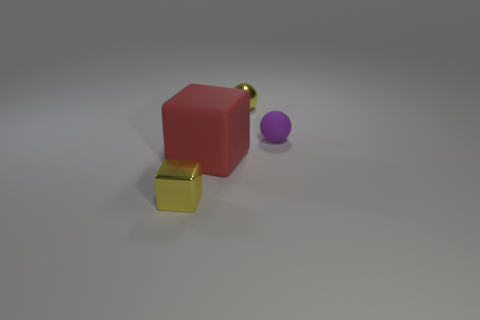Add 1 balls. How many objects exist? 5 Add 3 red rubber cubes. How many red rubber cubes exist? 4 Subtract 0 gray blocks. How many objects are left? 4 Subtract all large matte things. Subtract all large blue balls. How many objects are left? 3 Add 4 spheres. How many spheres are left? 6 